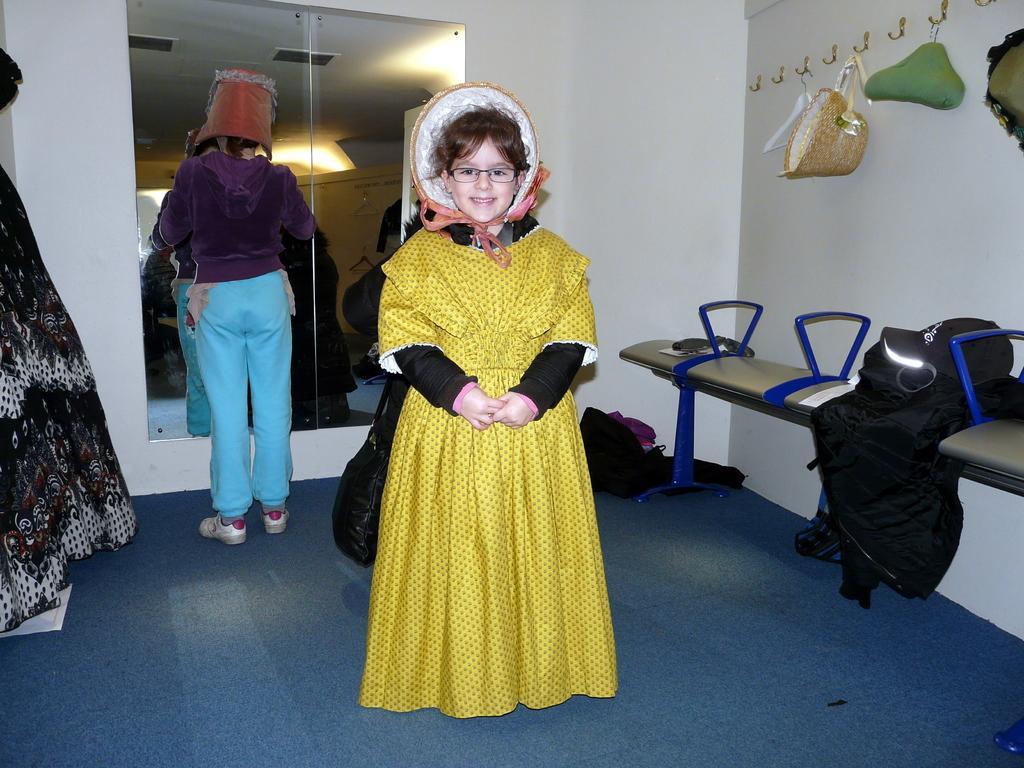Can you describe this image briefly? In the center of the image there is a girl standing on the ground. In the background we can see persons, mirror, hooks, chairs, hat clothes and wall. 